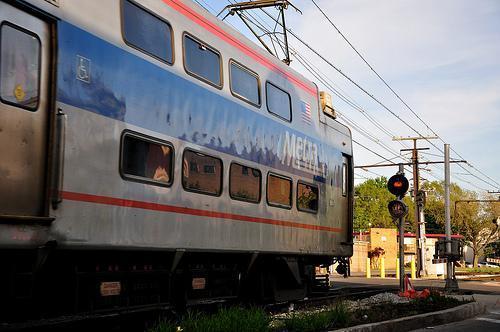How many trolleys are there?
Give a very brief answer. 1. How many people are walking near the train?
Give a very brief answer. 0. 